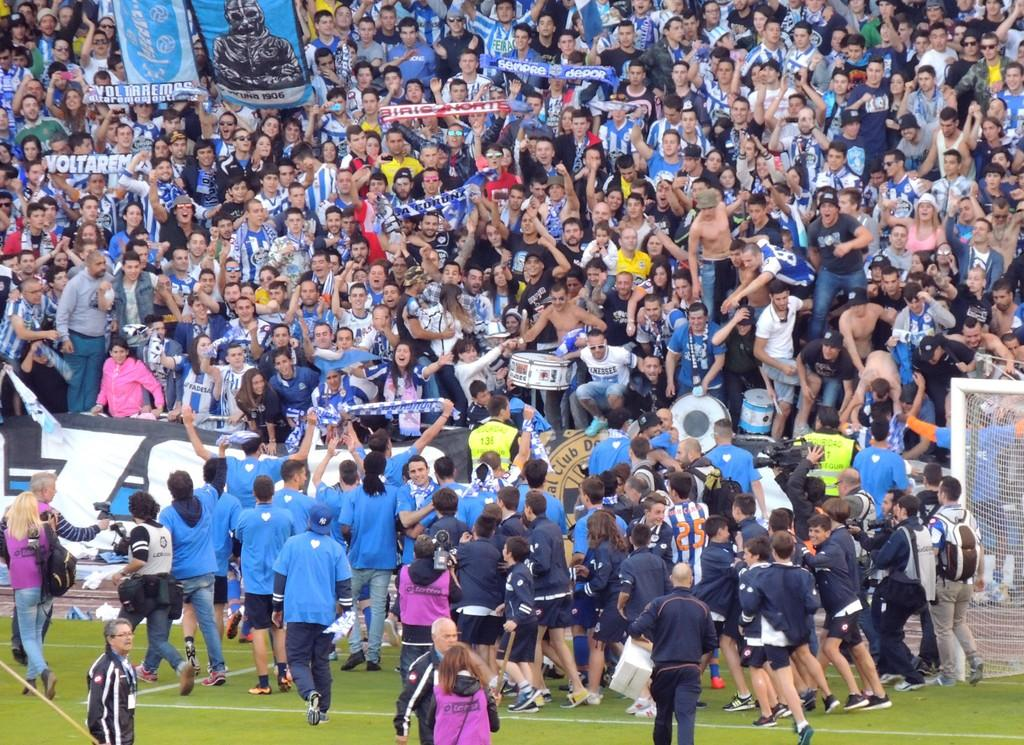<image>
Provide a brief description of the given image. Volteramas players celebrating with there fans in the stands 